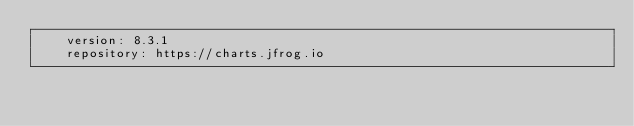<code> <loc_0><loc_0><loc_500><loc_500><_YAML_>    version: 8.3.1
    repository: https://charts.jfrog.io
</code> 